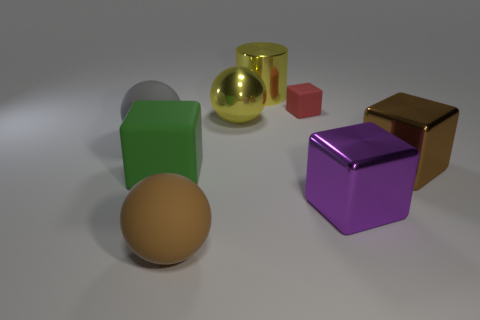There is a large yellow object that is behind the yellow metallic object that is in front of the red block; what shape is it?
Give a very brief answer. Cylinder. There is a gray thing; is it the same shape as the big yellow metal object that is behind the tiny red matte cube?
Keep it short and to the point. No. The rubber cube that is the same size as the metal cylinder is what color?
Give a very brief answer. Green. Is the number of spheres right of the brown matte sphere less than the number of large blocks that are right of the cylinder?
Your response must be concise. Yes. What is the shape of the brown object that is on the left side of the large metal thing in front of the brown thing that is to the right of the yellow shiny sphere?
Your answer should be very brief. Sphere. There is a metallic cylinder that is left of the tiny matte block; is it the same color as the large sphere that is behind the big gray sphere?
Your response must be concise. Yes. The big object that is the same color as the large cylinder is what shape?
Keep it short and to the point. Sphere. What number of rubber things are big green blocks or big gray spheres?
Ensure brevity in your answer.  2. There is a big sphere left of the matte thing in front of the metal thing that is in front of the brown metallic cube; what color is it?
Your response must be concise. Gray. What is the color of the large shiny thing that is the same shape as the big gray rubber object?
Offer a very short reply. Yellow. 